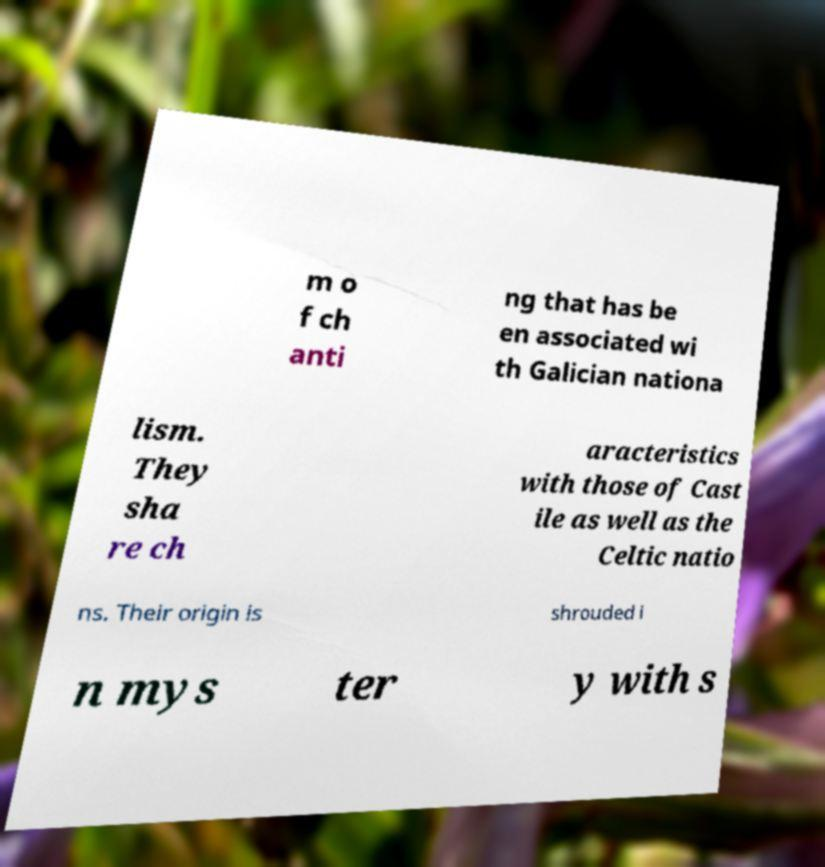Please read and relay the text visible in this image. What does it say? m o f ch anti ng that has be en associated wi th Galician nationa lism. They sha re ch aracteristics with those of Cast ile as well as the Celtic natio ns. Their origin is shrouded i n mys ter y with s 